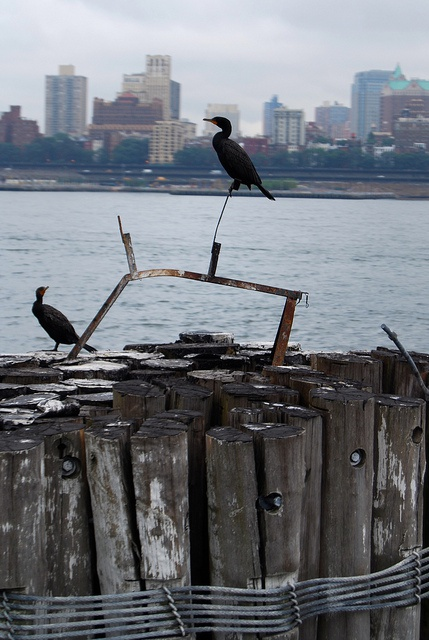Describe the objects in this image and their specific colors. I can see bird in lavender, black, gray, blue, and darkgray tones and bird in lavender, black, maroon, and gray tones in this image. 